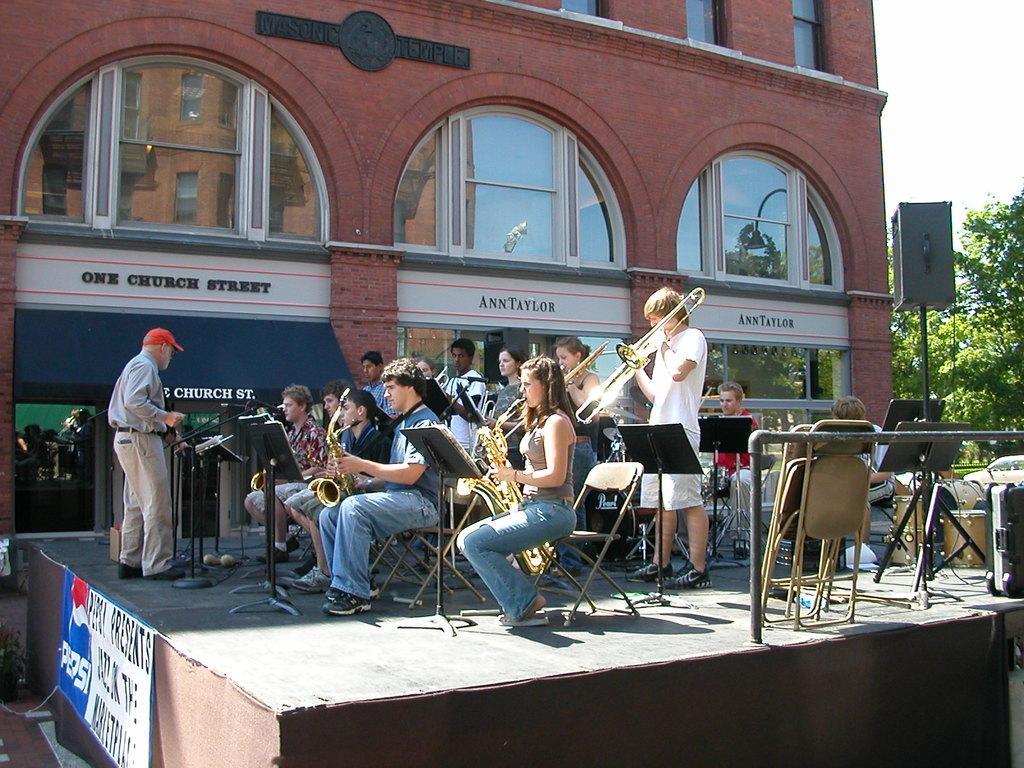Please provide a concise description of this image. In this image we can see people playing musical instruments. There are chairs and we can see a band. At the bottom there is a board and we can see a speaker. There are stands. In the background there is a building and we can see trees. There is sky. 